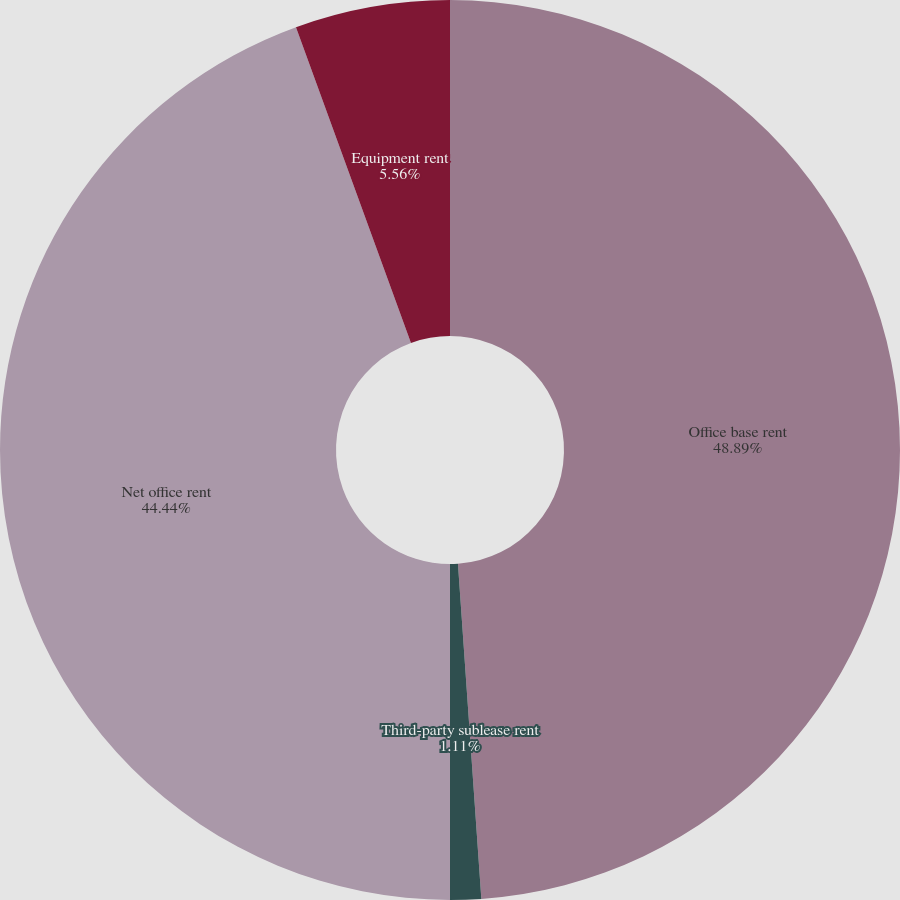Convert chart. <chart><loc_0><loc_0><loc_500><loc_500><pie_chart><fcel>Office base rent<fcel>Third-party sublease rent<fcel>Net office rent<fcel>Equipment rent<nl><fcel>48.89%<fcel>1.11%<fcel>44.44%<fcel>5.56%<nl></chart> 